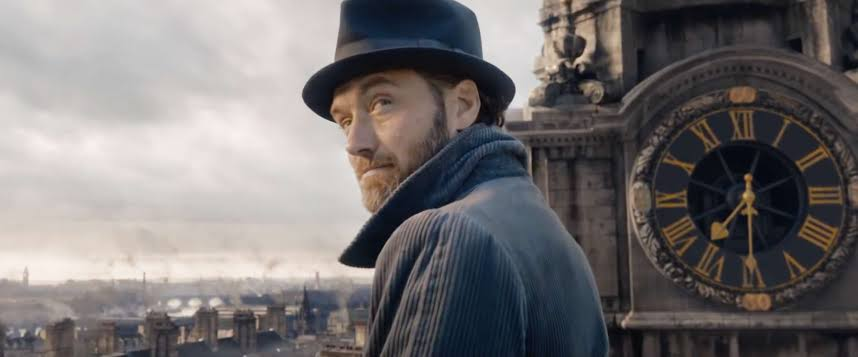What do you see happening in this image? The image portrays a man poised thoughtfully on a rooftop, clad in a layered blue coat and a dark top hat, set against the backdrop of a grand, intricate clock and a distant city skyline. His attire and beard suggest a historical or fantastical setting, evoking a character immersed in a moment of contemplation or decision. His gaze, directed towards something out of sight, along with the dramatic setting, suggests a narrative of intrigue and anticipation in a cinematic context. 